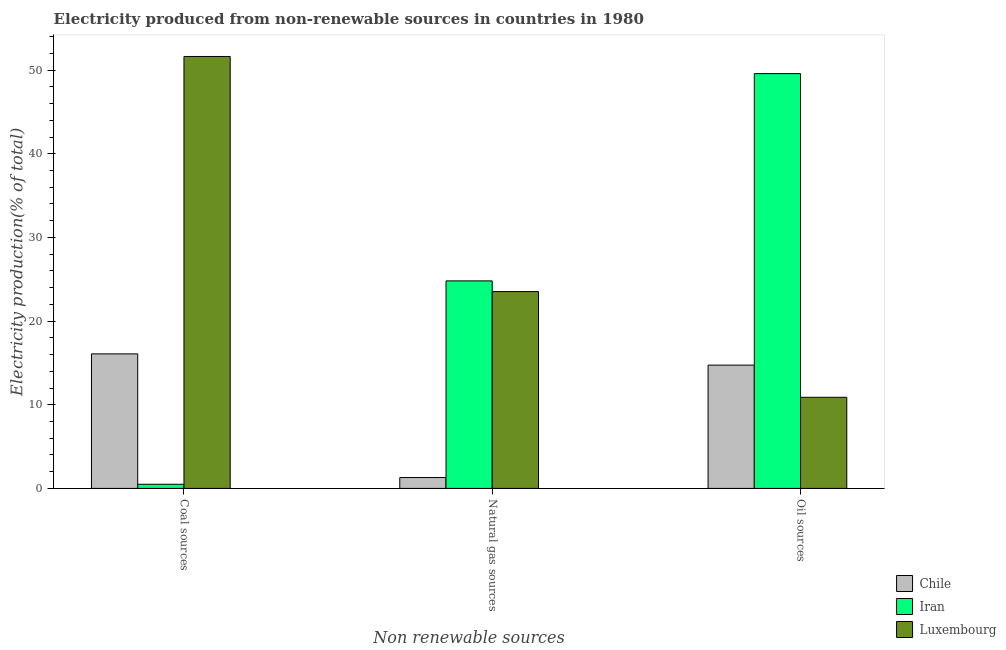How many groups of bars are there?
Your response must be concise. 3. How many bars are there on the 2nd tick from the left?
Provide a short and direct response. 3. How many bars are there on the 3rd tick from the right?
Keep it short and to the point. 3. What is the label of the 3rd group of bars from the left?
Offer a terse response. Oil sources. What is the percentage of electricity produced by oil sources in Chile?
Offer a terse response. 14.74. Across all countries, what is the maximum percentage of electricity produced by natural gas?
Provide a succinct answer. 24.81. Across all countries, what is the minimum percentage of electricity produced by oil sources?
Your answer should be very brief. 10.89. In which country was the percentage of electricity produced by oil sources maximum?
Your answer should be compact. Iran. In which country was the percentage of electricity produced by coal minimum?
Your response must be concise. Iran. What is the total percentage of electricity produced by oil sources in the graph?
Make the answer very short. 75.22. What is the difference between the percentage of electricity produced by natural gas in Chile and that in Luxembourg?
Offer a very short reply. -22.23. What is the difference between the percentage of electricity produced by coal in Chile and the percentage of electricity produced by natural gas in Luxembourg?
Your response must be concise. -7.45. What is the average percentage of electricity produced by oil sources per country?
Your answer should be very brief. 25.07. What is the difference between the percentage of electricity produced by coal and percentage of electricity produced by oil sources in Chile?
Your answer should be compact. 1.34. In how many countries, is the percentage of electricity produced by oil sources greater than 44 %?
Offer a terse response. 1. What is the ratio of the percentage of electricity produced by coal in Chile to that in Iran?
Provide a short and direct response. 32.43. Is the percentage of electricity produced by natural gas in Luxembourg less than that in Chile?
Make the answer very short. No. What is the difference between the highest and the second highest percentage of electricity produced by natural gas?
Ensure brevity in your answer.  1.28. What is the difference between the highest and the lowest percentage of electricity produced by coal?
Your answer should be compact. 51.14. In how many countries, is the percentage of electricity produced by oil sources greater than the average percentage of electricity produced by oil sources taken over all countries?
Provide a succinct answer. 1. What does the 1st bar from the left in Natural gas sources represents?
Offer a terse response. Chile. What does the 1st bar from the right in Oil sources represents?
Offer a very short reply. Luxembourg. What is the difference between two consecutive major ticks on the Y-axis?
Provide a short and direct response. 10. Are the values on the major ticks of Y-axis written in scientific E-notation?
Offer a terse response. No. Does the graph contain any zero values?
Your answer should be compact. No. Where does the legend appear in the graph?
Offer a terse response. Bottom right. How are the legend labels stacked?
Offer a very short reply. Vertical. What is the title of the graph?
Your answer should be compact. Electricity produced from non-renewable sources in countries in 1980. Does "Canada" appear as one of the legend labels in the graph?
Offer a very short reply. No. What is the label or title of the X-axis?
Ensure brevity in your answer.  Non renewable sources. What is the label or title of the Y-axis?
Provide a succinct answer. Electricity production(% of total). What is the Electricity production(% of total) in Chile in Coal sources?
Ensure brevity in your answer.  16.08. What is the Electricity production(% of total) of Iran in Coal sources?
Provide a short and direct response. 0.5. What is the Electricity production(% of total) of Luxembourg in Coal sources?
Provide a succinct answer. 51.63. What is the Electricity production(% of total) of Chile in Natural gas sources?
Keep it short and to the point. 1.3. What is the Electricity production(% of total) in Iran in Natural gas sources?
Offer a very short reply. 24.81. What is the Electricity production(% of total) in Luxembourg in Natural gas sources?
Give a very brief answer. 23.53. What is the Electricity production(% of total) in Chile in Oil sources?
Offer a terse response. 14.74. What is the Electricity production(% of total) of Iran in Oil sources?
Offer a very short reply. 49.58. What is the Electricity production(% of total) of Luxembourg in Oil sources?
Your response must be concise. 10.89. Across all Non renewable sources, what is the maximum Electricity production(% of total) of Chile?
Your answer should be compact. 16.08. Across all Non renewable sources, what is the maximum Electricity production(% of total) in Iran?
Give a very brief answer. 49.58. Across all Non renewable sources, what is the maximum Electricity production(% of total) of Luxembourg?
Your response must be concise. 51.63. Across all Non renewable sources, what is the minimum Electricity production(% of total) of Chile?
Make the answer very short. 1.3. Across all Non renewable sources, what is the minimum Electricity production(% of total) of Iran?
Provide a succinct answer. 0.5. Across all Non renewable sources, what is the minimum Electricity production(% of total) of Luxembourg?
Ensure brevity in your answer.  10.89. What is the total Electricity production(% of total) of Chile in the graph?
Provide a succinct answer. 32.12. What is the total Electricity production(% of total) of Iran in the graph?
Your response must be concise. 74.89. What is the total Electricity production(% of total) of Luxembourg in the graph?
Offer a very short reply. 86.06. What is the difference between the Electricity production(% of total) in Chile in Coal sources and that in Natural gas sources?
Offer a terse response. 14.78. What is the difference between the Electricity production(% of total) of Iran in Coal sources and that in Natural gas sources?
Provide a succinct answer. -24.31. What is the difference between the Electricity production(% of total) of Luxembourg in Coal sources and that in Natural gas sources?
Ensure brevity in your answer.  28.1. What is the difference between the Electricity production(% of total) of Chile in Coal sources and that in Oil sources?
Your answer should be compact. 1.34. What is the difference between the Electricity production(% of total) in Iran in Coal sources and that in Oil sources?
Keep it short and to the point. -49.09. What is the difference between the Electricity production(% of total) of Luxembourg in Coal sources and that in Oil sources?
Your answer should be compact. 40.74. What is the difference between the Electricity production(% of total) in Chile in Natural gas sources and that in Oil sources?
Offer a very short reply. -13.44. What is the difference between the Electricity production(% of total) in Iran in Natural gas sources and that in Oil sources?
Provide a succinct answer. -24.78. What is the difference between the Electricity production(% of total) in Luxembourg in Natural gas sources and that in Oil sources?
Give a very brief answer. 12.64. What is the difference between the Electricity production(% of total) of Chile in Coal sources and the Electricity production(% of total) of Iran in Natural gas sources?
Make the answer very short. -8.72. What is the difference between the Electricity production(% of total) in Chile in Coal sources and the Electricity production(% of total) in Luxembourg in Natural gas sources?
Provide a short and direct response. -7.45. What is the difference between the Electricity production(% of total) in Iran in Coal sources and the Electricity production(% of total) in Luxembourg in Natural gas sources?
Make the answer very short. -23.03. What is the difference between the Electricity production(% of total) of Chile in Coal sources and the Electricity production(% of total) of Iran in Oil sources?
Your response must be concise. -33.5. What is the difference between the Electricity production(% of total) in Chile in Coal sources and the Electricity production(% of total) in Luxembourg in Oil sources?
Make the answer very short. 5.19. What is the difference between the Electricity production(% of total) in Iran in Coal sources and the Electricity production(% of total) in Luxembourg in Oil sources?
Your answer should be compact. -10.4. What is the difference between the Electricity production(% of total) of Chile in Natural gas sources and the Electricity production(% of total) of Iran in Oil sources?
Provide a succinct answer. -48.28. What is the difference between the Electricity production(% of total) in Chile in Natural gas sources and the Electricity production(% of total) in Luxembourg in Oil sources?
Provide a succinct answer. -9.59. What is the difference between the Electricity production(% of total) in Iran in Natural gas sources and the Electricity production(% of total) in Luxembourg in Oil sources?
Provide a short and direct response. 13.91. What is the average Electricity production(% of total) in Chile per Non renewable sources?
Your answer should be compact. 10.71. What is the average Electricity production(% of total) in Iran per Non renewable sources?
Your answer should be compact. 24.96. What is the average Electricity production(% of total) of Luxembourg per Non renewable sources?
Keep it short and to the point. 28.69. What is the difference between the Electricity production(% of total) of Chile and Electricity production(% of total) of Iran in Coal sources?
Provide a short and direct response. 15.59. What is the difference between the Electricity production(% of total) in Chile and Electricity production(% of total) in Luxembourg in Coal sources?
Your answer should be compact. -35.55. What is the difference between the Electricity production(% of total) of Iran and Electricity production(% of total) of Luxembourg in Coal sources?
Provide a succinct answer. -51.14. What is the difference between the Electricity production(% of total) of Chile and Electricity production(% of total) of Iran in Natural gas sources?
Offer a terse response. -23.51. What is the difference between the Electricity production(% of total) in Chile and Electricity production(% of total) in Luxembourg in Natural gas sources?
Provide a succinct answer. -22.23. What is the difference between the Electricity production(% of total) of Iran and Electricity production(% of total) of Luxembourg in Natural gas sources?
Keep it short and to the point. 1.28. What is the difference between the Electricity production(% of total) in Chile and Electricity production(% of total) in Iran in Oil sources?
Make the answer very short. -34.85. What is the difference between the Electricity production(% of total) in Chile and Electricity production(% of total) in Luxembourg in Oil sources?
Ensure brevity in your answer.  3.85. What is the difference between the Electricity production(% of total) of Iran and Electricity production(% of total) of Luxembourg in Oil sources?
Provide a short and direct response. 38.69. What is the ratio of the Electricity production(% of total) of Chile in Coal sources to that in Natural gas sources?
Keep it short and to the point. 12.35. What is the ratio of the Electricity production(% of total) of Luxembourg in Coal sources to that in Natural gas sources?
Your response must be concise. 2.19. What is the ratio of the Electricity production(% of total) in Chile in Coal sources to that in Oil sources?
Give a very brief answer. 1.09. What is the ratio of the Electricity production(% of total) in Luxembourg in Coal sources to that in Oil sources?
Offer a terse response. 4.74. What is the ratio of the Electricity production(% of total) of Chile in Natural gas sources to that in Oil sources?
Your answer should be compact. 0.09. What is the ratio of the Electricity production(% of total) of Iran in Natural gas sources to that in Oil sources?
Provide a succinct answer. 0.5. What is the ratio of the Electricity production(% of total) in Luxembourg in Natural gas sources to that in Oil sources?
Provide a succinct answer. 2.16. What is the difference between the highest and the second highest Electricity production(% of total) in Chile?
Ensure brevity in your answer.  1.34. What is the difference between the highest and the second highest Electricity production(% of total) in Iran?
Offer a very short reply. 24.78. What is the difference between the highest and the second highest Electricity production(% of total) of Luxembourg?
Offer a terse response. 28.1. What is the difference between the highest and the lowest Electricity production(% of total) of Chile?
Provide a succinct answer. 14.78. What is the difference between the highest and the lowest Electricity production(% of total) in Iran?
Your response must be concise. 49.09. What is the difference between the highest and the lowest Electricity production(% of total) of Luxembourg?
Provide a short and direct response. 40.74. 